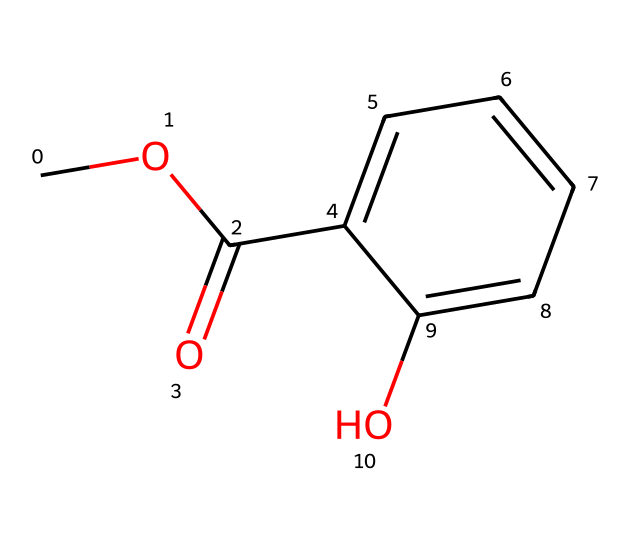What is the name of this compound? The SMILES representation shows a methyl group (from "CO"), a carbonyl group (from "C(=O)"), and a hydroxyl group (from "O") connected to a benzene ring (from "c1ccccc1"). Together, these components indicate that this compound is methyl salicylate, known for its wintergreen scent.
Answer: methyl salicylate How many oxygen atoms are present in the structure? In the SMILES representation, there are two occurrences of "O" (one in the methyl group and one in the carbonyl/hydroxyl groups). Counting these gives a total of two oxygen atoms in the entire molecule.
Answer: 2 What type of functional group does methyl salicylate contain? The structure includes a carbonyl group (C=O) and an ester functional group (C-O-C). Given its characteristic structure with a carbonyl and an ether linkage, methyl salicylate belongs to the ester class of compounds.
Answer: ester What is the ester group derived from in methyl salicylate? The "meth" in methyl salicylate refers to the methyl alcohol (methanol) that provides the ester part of the molecule. The rest of the molecule is derived from salicylic acid, which contributes the aromatic and hydroxyl portions.
Answer: methanol How many carbon atoms are present in the structure of methyl salicylate? By analyzing the SMILES, we see "C" three times directly plus the carbons in the benzene part (six in a benzene ring). Adding these counts together gives a total of nine carbon atoms in the complete structure.
Answer: 9 